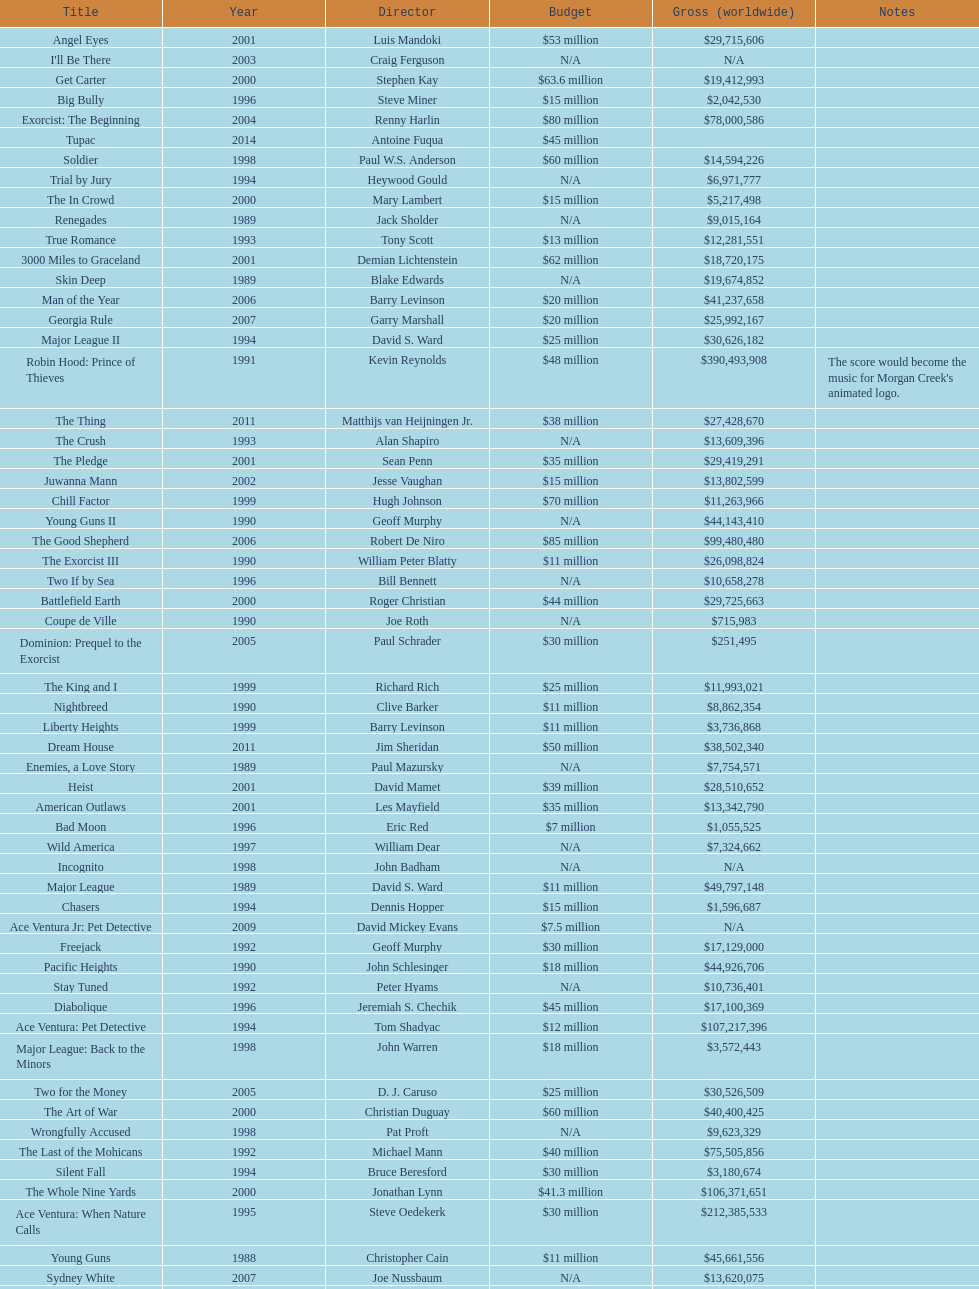What is the top grossing film? Robin Hood: Prince of Thieves. 